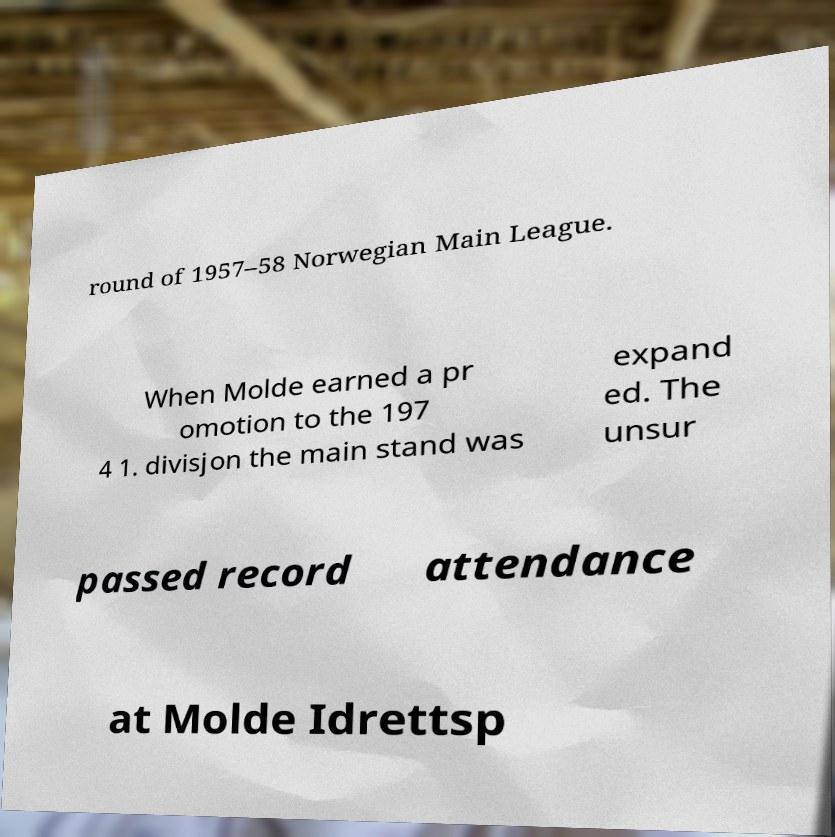Could you assist in decoding the text presented in this image and type it out clearly? round of 1957–58 Norwegian Main League. When Molde earned a pr omotion to the 197 4 1. divisjon the main stand was expand ed. The unsur passed record attendance at Molde Idrettsp 